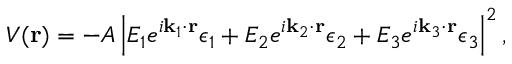<formula> <loc_0><loc_0><loc_500><loc_500>V ( r ) = - A \left | E _ { 1 } e ^ { i k _ { 1 } \cdot r } \epsilon _ { 1 } + E _ { 2 } e ^ { i k _ { 2 } \cdot r } \epsilon _ { 2 } + E _ { 3 } e ^ { i k _ { 3 } \cdot r } \epsilon _ { 3 } \right | ^ { 2 } ,</formula> 